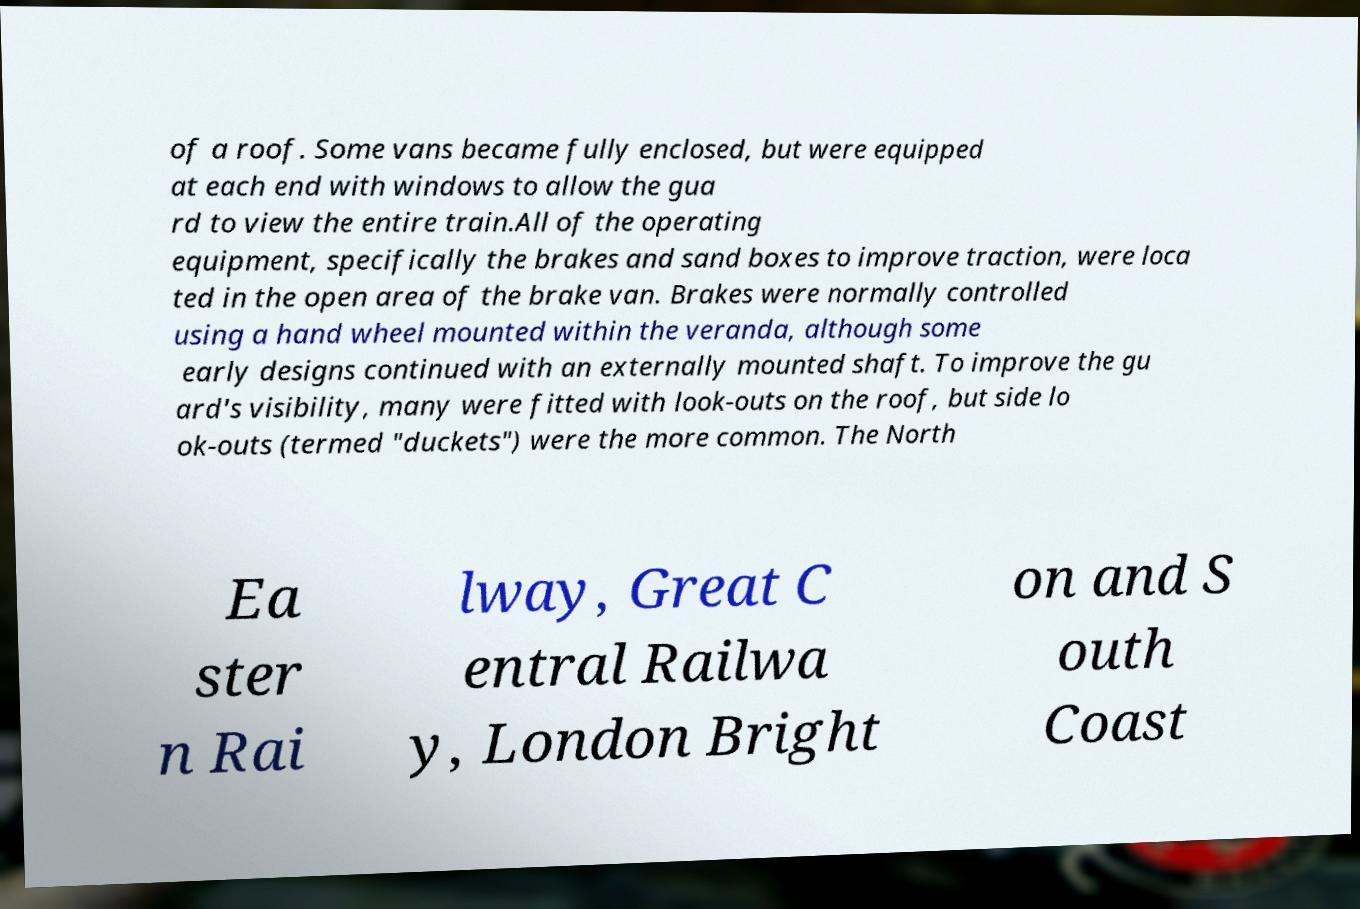Could you assist in decoding the text presented in this image and type it out clearly? of a roof. Some vans became fully enclosed, but were equipped at each end with windows to allow the gua rd to view the entire train.All of the operating equipment, specifically the brakes and sand boxes to improve traction, were loca ted in the open area of the brake van. Brakes were normally controlled using a hand wheel mounted within the veranda, although some early designs continued with an externally mounted shaft. To improve the gu ard's visibility, many were fitted with look-outs on the roof, but side lo ok-outs (termed "duckets") were the more common. The North Ea ster n Rai lway, Great C entral Railwa y, London Bright on and S outh Coast 